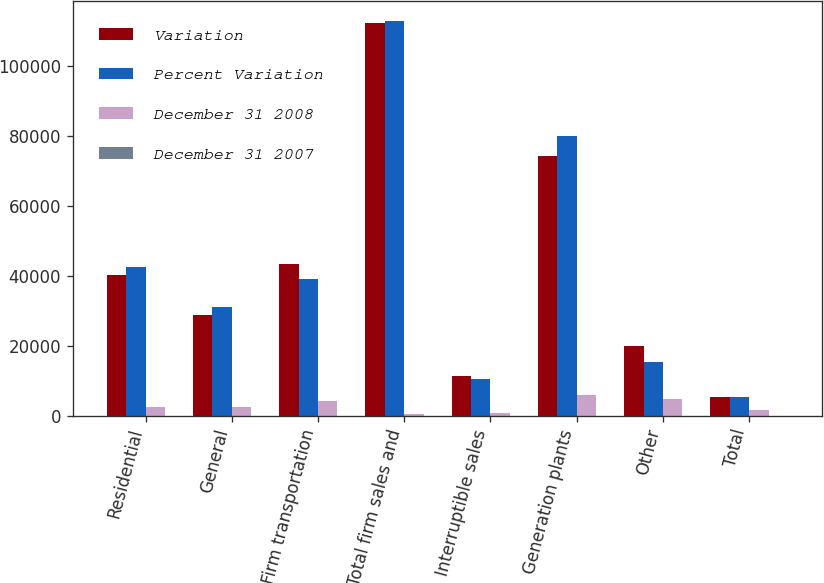Convert chart. <chart><loc_0><loc_0><loc_500><loc_500><stacked_bar_chart><ecel><fcel>Residential<fcel>General<fcel>Firm transportation<fcel>Total firm sales and<fcel>Interruptible sales<fcel>Generation plants<fcel>Other<fcel>Total<nl><fcel>Variation<fcel>40195<fcel>28748<fcel>43245<fcel>112188<fcel>11220<fcel>74082<fcel>20004<fcel>5273<nl><fcel>Percent Variation<fcel>42573<fcel>31162<fcel>39016<fcel>112751<fcel>10577<fcel>79942<fcel>15318<fcel>5273<nl><fcel>December 31 2008<fcel>2378<fcel>2414<fcel>4229<fcel>563<fcel>643<fcel>5860<fcel>4686<fcel>1515<nl><fcel>December 31 2007<fcel>5.6<fcel>7.7<fcel>10.8<fcel>0.5<fcel>6.1<fcel>7.3<fcel>30.6<fcel>0.6<nl></chart> 